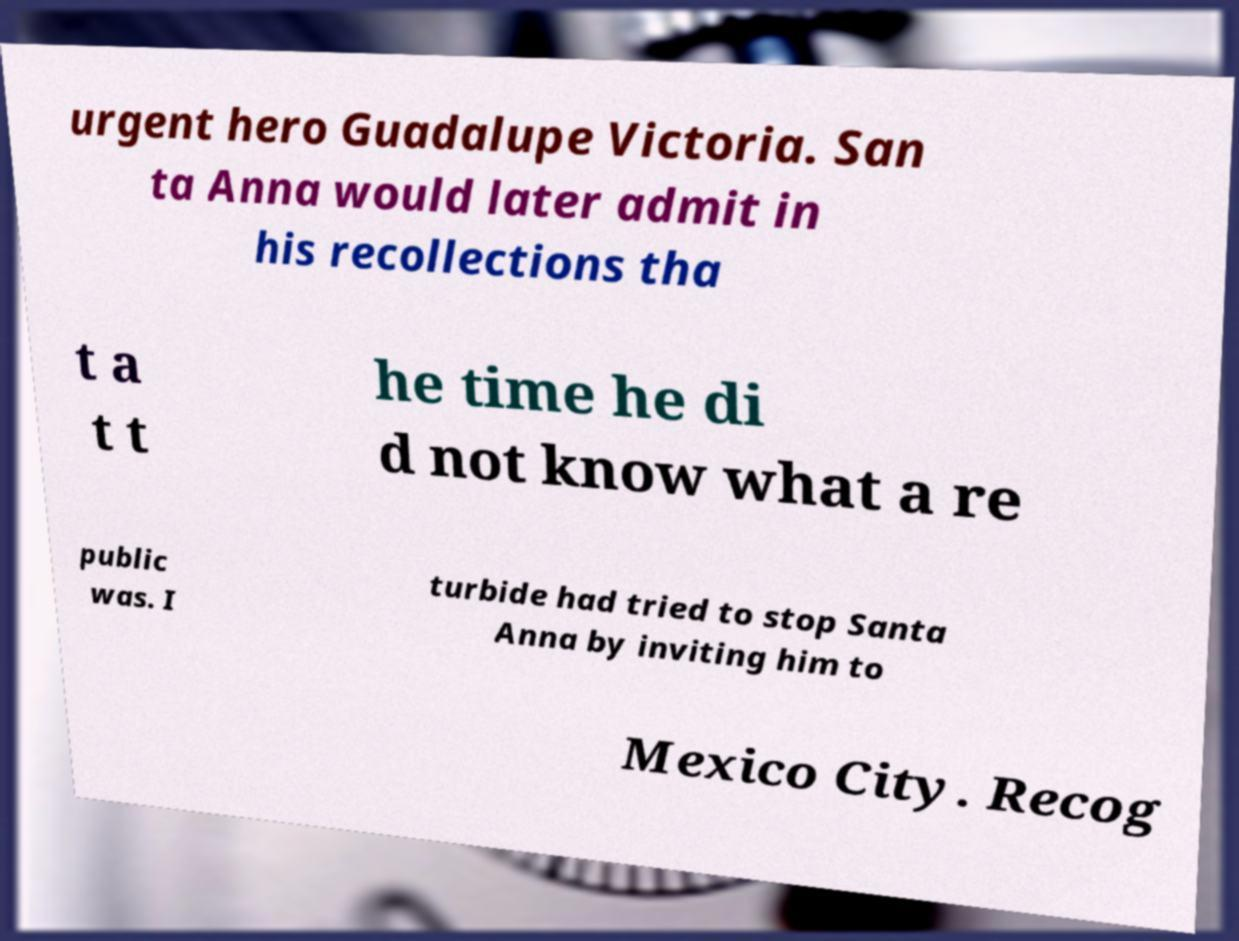What messages or text are displayed in this image? I need them in a readable, typed format. urgent hero Guadalupe Victoria. San ta Anna would later admit in his recollections tha t a t t he time he di d not know what a re public was. I turbide had tried to stop Santa Anna by inviting him to Mexico City. Recog 